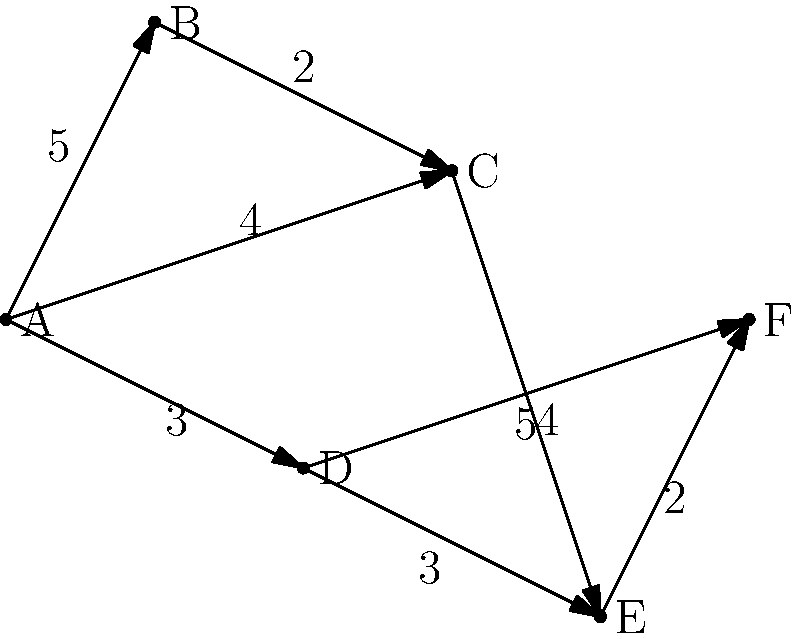Given the network diagram representing potential public transportation routes between six urban centers (A, B, C, D, E, and F), with edge weights indicating travel time in minutes, determine the optimal route from point A to point F that minimizes total travel time. To find the optimal route from A to F with minimum total travel time, we need to apply Dijkstra's algorithm:

1. Initialize:
   - Set A's distance to 0 and all other nodes to infinity.
   - Mark all nodes as unvisited.

2. For the current node (starting with A), consider all unvisited neighbors and calculate their tentative distances.
   - A to B: 5 minutes
   - A to C: 4 minutes
   - A to D: 3 minutes

3. Mark A as visited. B (5 min), C (4 min), and D (3 min) are now in the unvisited set.

4. Select D as the new current node (lowest tentative distance).
   - D to E: 3 + 3 = 6 minutes
   - D to F: 3 + 5 = 8 minutes

5. Mark D as visited. Unvisited set: B (5), C (4), E (6), F (8).

6. Select C as the new current node.
   - C to E: 4 + 4 = 8 minutes (higher than current E, so no update)

7. Mark C as visited. Unvisited set: B (5), E (6), F (8).

8. Select B as the new current node. No unvisited neighbors.

9. Mark B as visited. Unvisited set: E (6), F (8).

10. Select E as the new current node.
    - E to F: 6 + 2 = 8 minutes (same as current F, so no update)

11. Mark E as visited. Unvisited set: F (8).

12. F is the only remaining node. Algorithm complete.

The optimal route is A -> D -> E -> F with a total travel time of 8 minutes.
Answer: A -> D -> E -> F (8 minutes) 